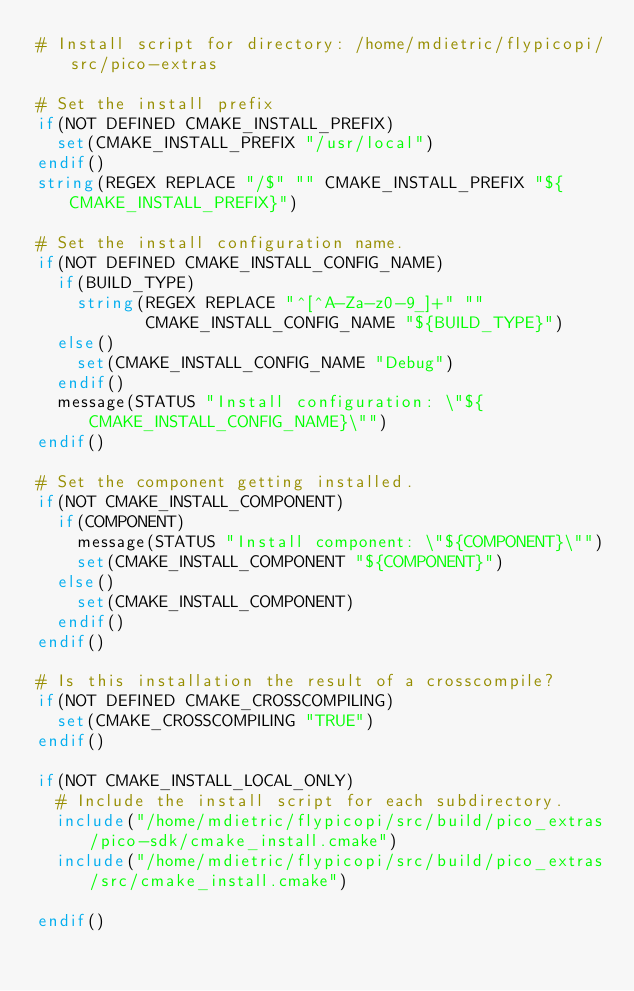Convert code to text. <code><loc_0><loc_0><loc_500><loc_500><_CMake_># Install script for directory: /home/mdietric/flypicopi/src/pico-extras

# Set the install prefix
if(NOT DEFINED CMAKE_INSTALL_PREFIX)
  set(CMAKE_INSTALL_PREFIX "/usr/local")
endif()
string(REGEX REPLACE "/$" "" CMAKE_INSTALL_PREFIX "${CMAKE_INSTALL_PREFIX}")

# Set the install configuration name.
if(NOT DEFINED CMAKE_INSTALL_CONFIG_NAME)
  if(BUILD_TYPE)
    string(REGEX REPLACE "^[^A-Za-z0-9_]+" ""
           CMAKE_INSTALL_CONFIG_NAME "${BUILD_TYPE}")
  else()
    set(CMAKE_INSTALL_CONFIG_NAME "Debug")
  endif()
  message(STATUS "Install configuration: \"${CMAKE_INSTALL_CONFIG_NAME}\"")
endif()

# Set the component getting installed.
if(NOT CMAKE_INSTALL_COMPONENT)
  if(COMPONENT)
    message(STATUS "Install component: \"${COMPONENT}\"")
    set(CMAKE_INSTALL_COMPONENT "${COMPONENT}")
  else()
    set(CMAKE_INSTALL_COMPONENT)
  endif()
endif()

# Is this installation the result of a crosscompile?
if(NOT DEFINED CMAKE_CROSSCOMPILING)
  set(CMAKE_CROSSCOMPILING "TRUE")
endif()

if(NOT CMAKE_INSTALL_LOCAL_ONLY)
  # Include the install script for each subdirectory.
  include("/home/mdietric/flypicopi/src/build/pico_extras/pico-sdk/cmake_install.cmake")
  include("/home/mdietric/flypicopi/src/build/pico_extras/src/cmake_install.cmake")

endif()

</code> 